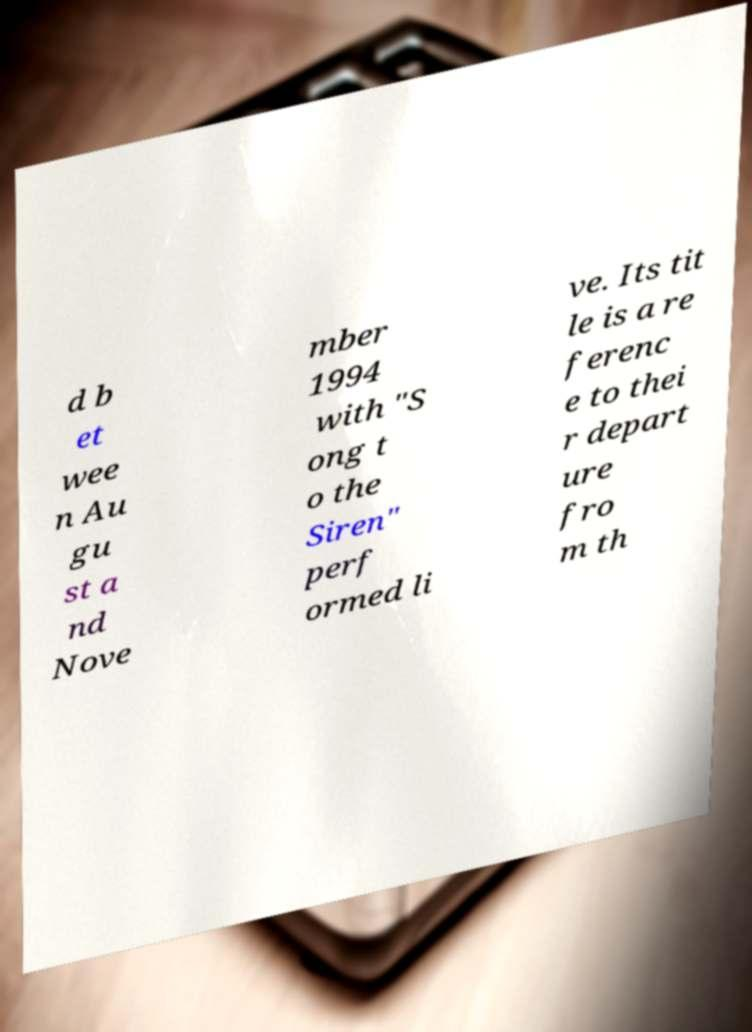Can you accurately transcribe the text from the provided image for me? d b et wee n Au gu st a nd Nove mber 1994 with "S ong t o the Siren" perf ormed li ve. Its tit le is a re ferenc e to thei r depart ure fro m th 